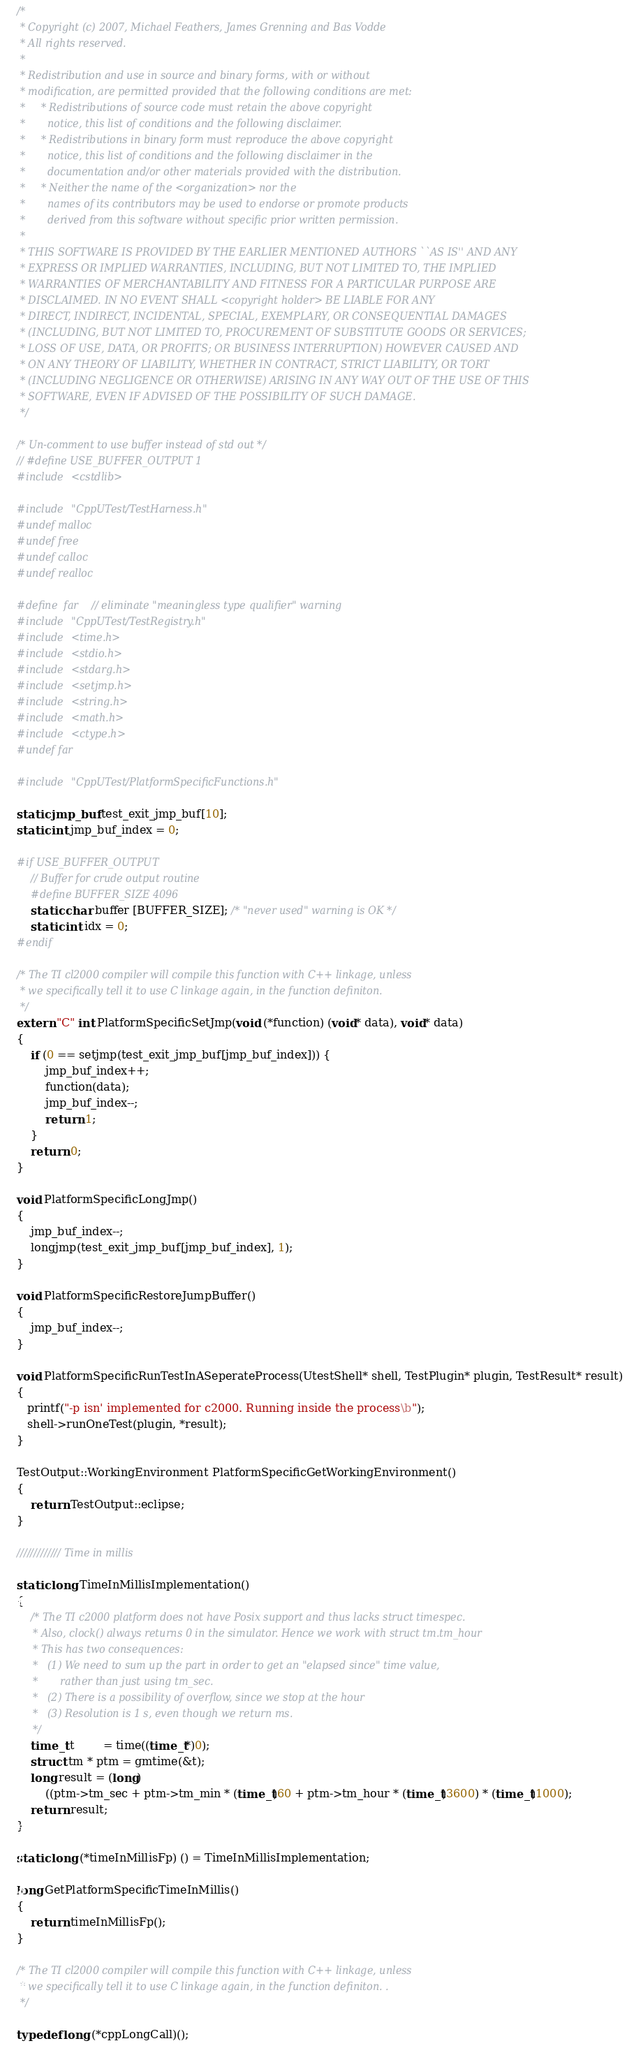<code> <loc_0><loc_0><loc_500><loc_500><_C++_>/*
 * Copyright (c) 2007, Michael Feathers, James Grenning and Bas Vodde
 * All rights reserved.
 *
 * Redistribution and use in source and binary forms, with or without
 * modification, are permitted provided that the following conditions are met:
 *     * Redistributions of source code must retain the above copyright
 *       notice, this list of conditions and the following disclaimer.
 *     * Redistributions in binary form must reproduce the above copyright
 *       notice, this list of conditions and the following disclaimer in the
 *       documentation and/or other materials provided with the distribution.
 *     * Neither the name of the <organization> nor the
 *       names of its contributors may be used to endorse or promote products
 *       derived from this software without specific prior written permission.
 *
 * THIS SOFTWARE IS PROVIDED BY THE EARLIER MENTIONED AUTHORS ``AS IS'' AND ANY
 * EXPRESS OR IMPLIED WARRANTIES, INCLUDING, BUT NOT LIMITED TO, THE IMPLIED
 * WARRANTIES OF MERCHANTABILITY AND FITNESS FOR A PARTICULAR PURPOSE ARE
 * DISCLAIMED. IN NO EVENT SHALL <copyright holder> BE LIABLE FOR ANY
 * DIRECT, INDIRECT, INCIDENTAL, SPECIAL, EXEMPLARY, OR CONSEQUENTIAL DAMAGES
 * (INCLUDING, BUT NOT LIMITED TO, PROCUREMENT OF SUBSTITUTE GOODS OR SERVICES;
 * LOSS OF USE, DATA, OR PROFITS; OR BUSINESS INTERRUPTION) HOWEVER CAUSED AND
 * ON ANY THEORY OF LIABILITY, WHETHER IN CONTRACT, STRICT LIABILITY, OR TORT
 * (INCLUDING NEGLIGENCE OR OTHERWISE) ARISING IN ANY WAY OUT OF THE USE OF THIS
 * SOFTWARE, EVEN IF ADVISED OF THE POSSIBILITY OF SUCH DAMAGE.
 */

/* Un-comment to use buffer instead of std out */
// #define USE_BUFFER_OUTPUT 1
#include <cstdlib>

#include "CppUTest/TestHarness.h"
#undef malloc
#undef free
#undef calloc
#undef realloc

#define  far  // eliminate "meaningless type qualifier" warning
#include "CppUTest/TestRegistry.h"
#include <time.h>
#include <stdio.h>
#include <stdarg.h>
#include <setjmp.h>
#include <string.h>
#include <math.h>
#include <ctype.h>
#undef far

#include "CppUTest/PlatformSpecificFunctions.h"

static jmp_buf test_exit_jmp_buf[10];
static int jmp_buf_index = 0;

#if USE_BUFFER_OUTPUT
    // Buffer for crude output routine 
    #define BUFFER_SIZE 4096
    static char buffer [BUFFER_SIZE]; /* "never used" warning is OK */
    static int idx = 0;
#endif

/* The TI cl2000 compiler will compile this function with C++ linkage, unless
 * we specifically tell it to use C linkage again, in the function definiton.
 */
extern "C" int PlatformSpecificSetJmp(void (*function) (void* data), void* data)
{
	if (0 == setjmp(test_exit_jmp_buf[jmp_buf_index])) {
	    jmp_buf_index++;
		function(data);
	    jmp_buf_index--;
		return 1;
	}
	return 0;
}

void PlatformSpecificLongJmp()
{
	jmp_buf_index--;
	longjmp(test_exit_jmp_buf[jmp_buf_index], 1);
}

void PlatformSpecificRestoreJumpBuffer()
{
	jmp_buf_index--;
}

void PlatformSpecificRunTestInASeperateProcess(UtestShell* shell, TestPlugin* plugin, TestResult* result)
{
   printf("-p isn' implemented for c2000. Running inside the process\b");
   shell->runOneTest(plugin, *result);
}

TestOutput::WorkingEnvironment PlatformSpecificGetWorkingEnvironment()
{
	return TestOutput::eclipse;
}

///////////// Time in millis

static long TimeInMillisImplementation()
{
    /* The TI c2000 platform does not have Posix support and thus lacks struct timespec.
     * Also, clock() always returns 0 in the simulator. Hence we work with struct tm.tm_hour
	 * This has two consequences:
	 *   (1) We need to sum up the part in order to get an "elapsed since" time value,
	 *       rather than just using tm_sec.
	 *   (2) There is a possibility of overflow, since we stop at the hour
	 *   (3) Resolution is 1 s, even though we return ms.
	 */
	time_t t        = time((time_t*)0);
    struct tm * ptm = gmtime(&t);
	long result = (long)
        ((ptm->tm_sec + ptm->tm_min * (time_t)60 + ptm->tm_hour * (time_t)3600) * (time_t)1000);
	return result;
}

static long (*timeInMillisFp) () = TimeInMillisImplementation;

long GetPlatformSpecificTimeInMillis()
{
	return timeInMillisFp();
}

/* The TI cl2000 compiler will compile this function with C++ linkage, unless
 * we specifically tell it to use C linkage again, in the function definiton. .
 */

typedef long (*cppLongCall)();
</code> 